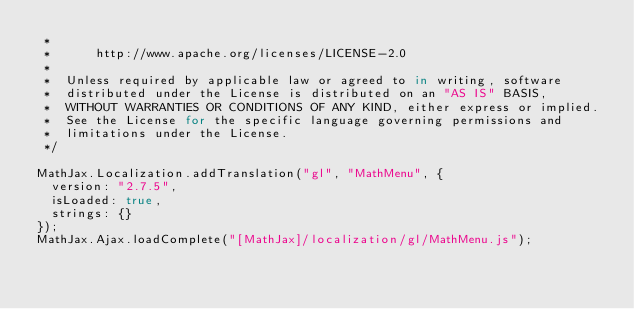Convert code to text. <code><loc_0><loc_0><loc_500><loc_500><_JavaScript_> *
 *      http://www.apache.org/licenses/LICENSE-2.0
 *
 *  Unless required by applicable law or agreed to in writing, software
 *  distributed under the License is distributed on an "AS IS" BASIS,
 *  WITHOUT WARRANTIES OR CONDITIONS OF ANY KIND, either express or implied.
 *  See the License for the specific language governing permissions and
 *  limitations under the License.
 */

MathJax.Localization.addTranslation("gl", "MathMenu", {
  version: "2.7.5",
  isLoaded: true,
  strings: {}
});
MathJax.Ajax.loadComplete("[MathJax]/localization/gl/MathMenu.js");
</code> 